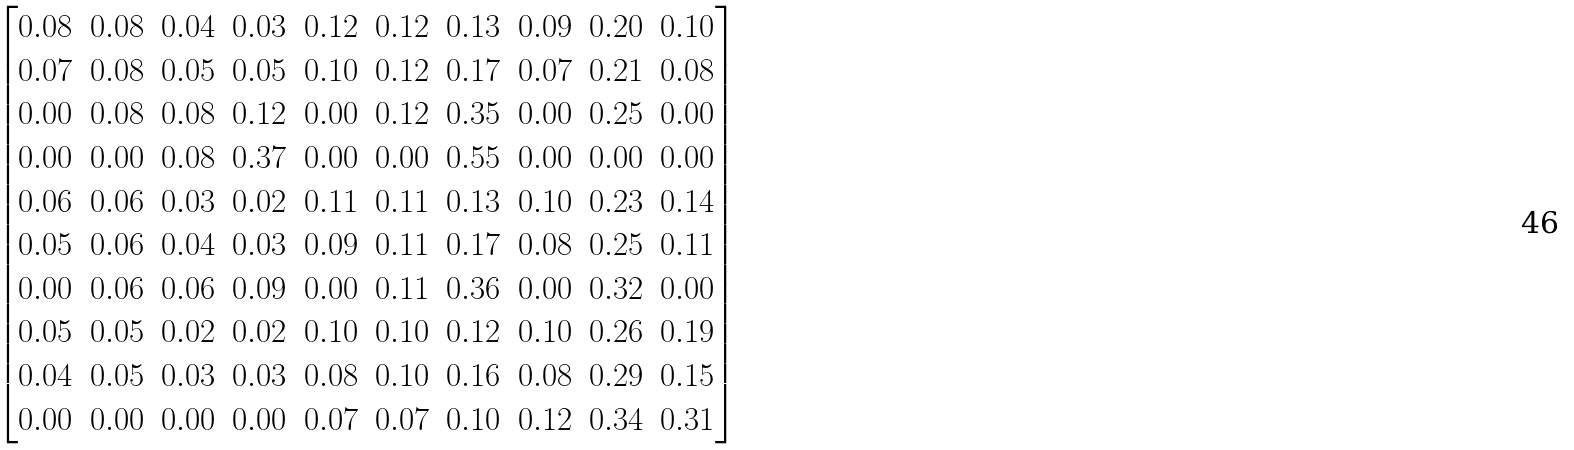Convert formula to latex. <formula><loc_0><loc_0><loc_500><loc_500>\begin{bmatrix} 0 . 0 8 & 0 . 0 8 & 0 . 0 4 & 0 . 0 3 & 0 . 1 2 & 0 . 1 2 & 0 . 1 3 & 0 . 0 9 & 0 . 2 0 & 0 . 1 0 \\ 0 . 0 7 & 0 . 0 8 & 0 . 0 5 & 0 . 0 5 & 0 . 1 0 & 0 . 1 2 & 0 . 1 7 & 0 . 0 7 & 0 . 2 1 & 0 . 0 8 \\ 0 . 0 0 & 0 . 0 8 & 0 . 0 8 & 0 . 1 2 & 0 . 0 0 & 0 . 1 2 & 0 . 3 5 & 0 . 0 0 & 0 . 2 5 & 0 . 0 0 \\ 0 . 0 0 & 0 . 0 0 & 0 . 0 8 & 0 . 3 7 & 0 . 0 0 & 0 . 0 0 & 0 . 5 5 & 0 . 0 0 & 0 . 0 0 & 0 . 0 0 \\ 0 . 0 6 & 0 . 0 6 & 0 . 0 3 & 0 . 0 2 & 0 . 1 1 & 0 . 1 1 & 0 . 1 3 & 0 . 1 0 & 0 . 2 3 & 0 . 1 4 \\ 0 . 0 5 & 0 . 0 6 & 0 . 0 4 & 0 . 0 3 & 0 . 0 9 & 0 . 1 1 & 0 . 1 7 & 0 . 0 8 & 0 . 2 5 & 0 . 1 1 \\ 0 . 0 0 & 0 . 0 6 & 0 . 0 6 & 0 . 0 9 & 0 . 0 0 & 0 . 1 1 & 0 . 3 6 & 0 . 0 0 & 0 . 3 2 & 0 . 0 0 \\ 0 . 0 5 & 0 . 0 5 & 0 . 0 2 & 0 . 0 2 & 0 . 1 0 & 0 . 1 0 & 0 . 1 2 & 0 . 1 0 & 0 . 2 6 & 0 . 1 9 \\ 0 . 0 4 & 0 . 0 5 & 0 . 0 3 & 0 . 0 3 & 0 . 0 8 & 0 . 1 0 & 0 . 1 6 & 0 . 0 8 & 0 . 2 9 & 0 . 1 5 \\ 0 . 0 0 & 0 . 0 0 & 0 . 0 0 & 0 . 0 0 & 0 . 0 7 & 0 . 0 7 & 0 . 1 0 & 0 . 1 2 & 0 . 3 4 & 0 . 3 1 \end{bmatrix}</formula> 